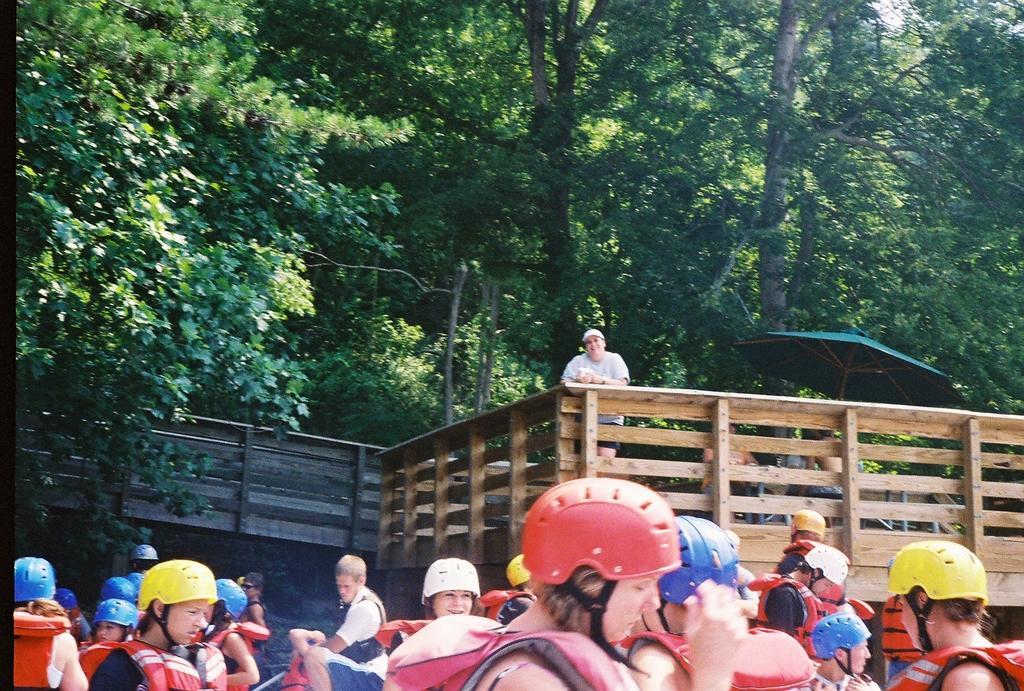In one or two sentences, can you explain what this image depicts? In the picture I can see people among them a person is standing behind the wooden fence and the people in front of the image are wearing helmets and some other objects. In the background I can see trees, an umbrella and some other objects. 